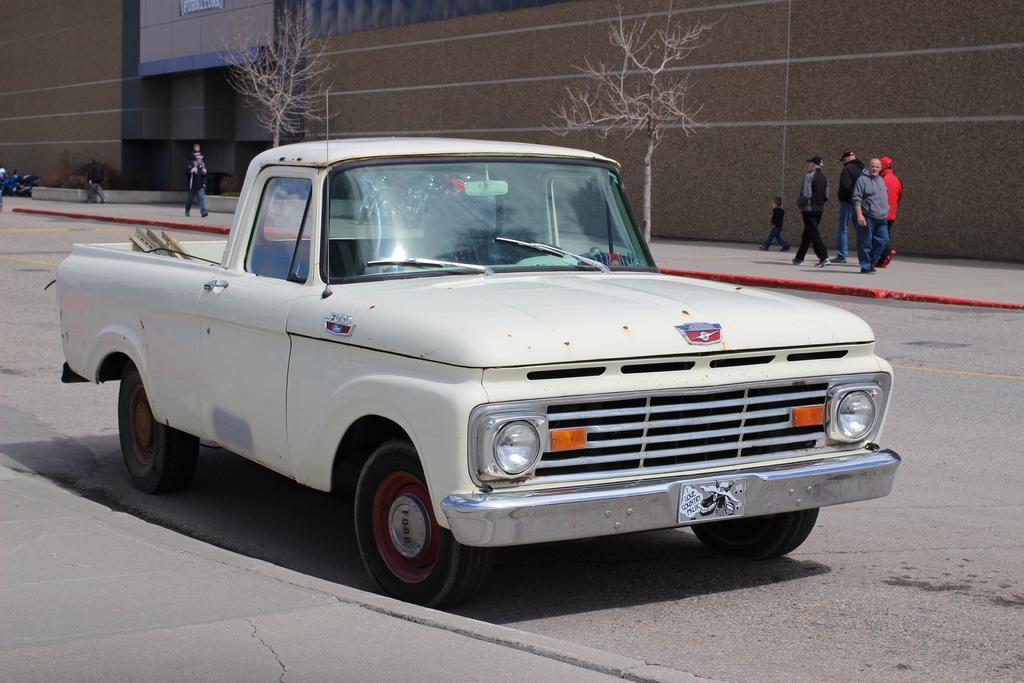Please provide a concise description of this image. In this image we can see a car placed on the road. On the backside we can see a group of people standing on the footpath. In that a man is carrying a child. We can also see some trees and a building. 